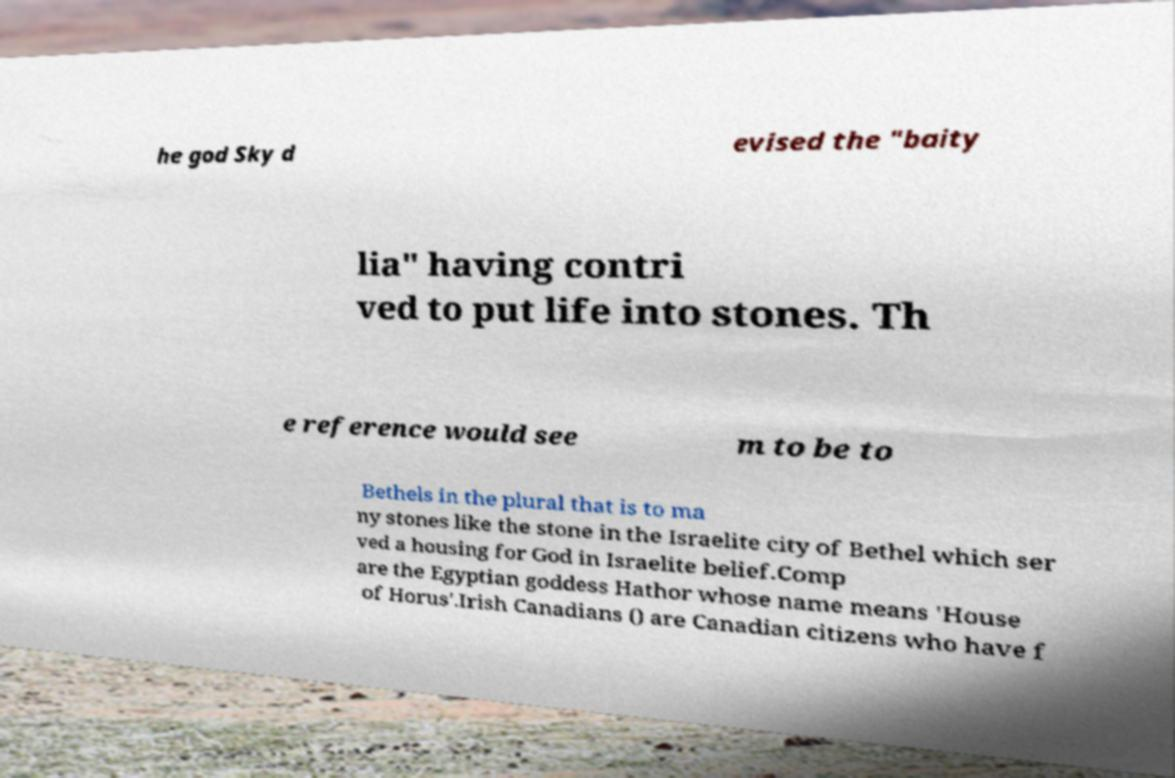There's text embedded in this image that I need extracted. Can you transcribe it verbatim? he god Sky d evised the "baity lia" having contri ved to put life into stones. Th e reference would see m to be to Bethels in the plural that is to ma ny stones like the stone in the Israelite city of Bethel which ser ved a housing for God in Israelite belief.Comp are the Egyptian goddess Hathor whose name means 'House of Horus'.Irish Canadians () are Canadian citizens who have f 